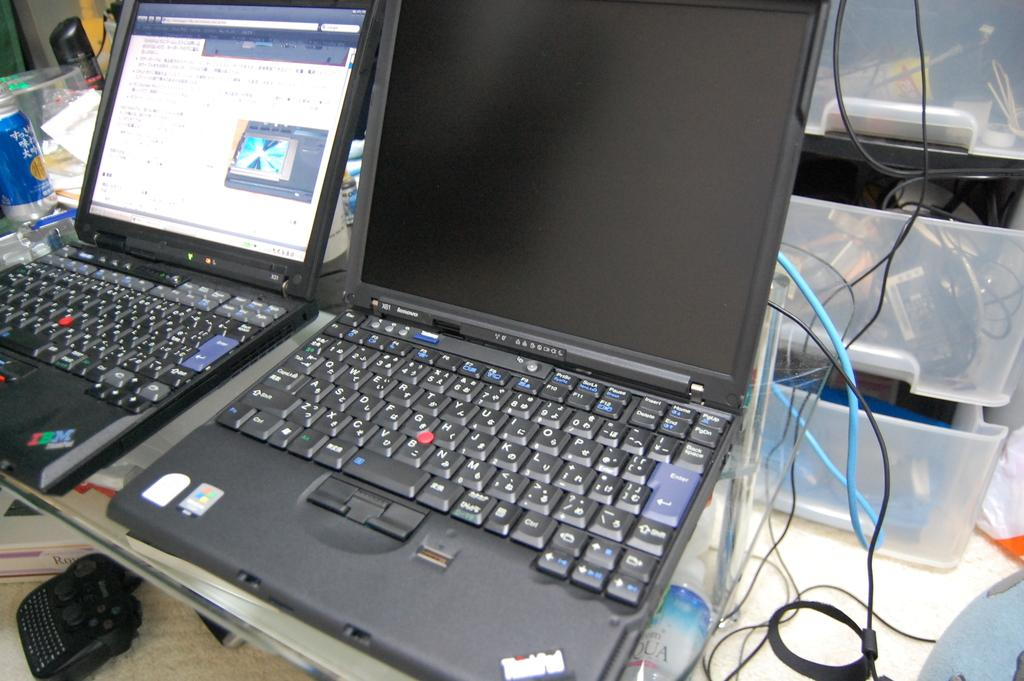<image>
Summarize the visual content of the image. The laptop on the counter has a IBM sticker on it. 